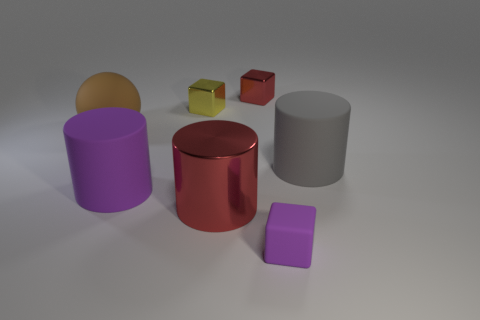What number of other objects are there of the same shape as the tiny purple object?
Ensure brevity in your answer.  2. There is a gray thing that is in front of the yellow cube; is it the same shape as the tiny purple rubber thing?
Your response must be concise. No. Are there any purple matte things behind the big ball?
Offer a very short reply. No. How many large objects are red matte things or metal cylinders?
Provide a short and direct response. 1. Is the material of the brown object the same as the big purple object?
Provide a short and direct response. Yes. There is a thing that is the same color as the metal cylinder; what size is it?
Your response must be concise. Small. Is there another big metallic object that has the same color as the big metallic thing?
Make the answer very short. No. The gray thing that is the same material as the tiny purple object is what size?
Your response must be concise. Large. The red thing that is in front of the matte cylinder that is to the right of the purple rubber thing on the left side of the rubber block is what shape?
Offer a very short reply. Cylinder. The red object that is the same shape as the tiny purple object is what size?
Offer a very short reply. Small. 